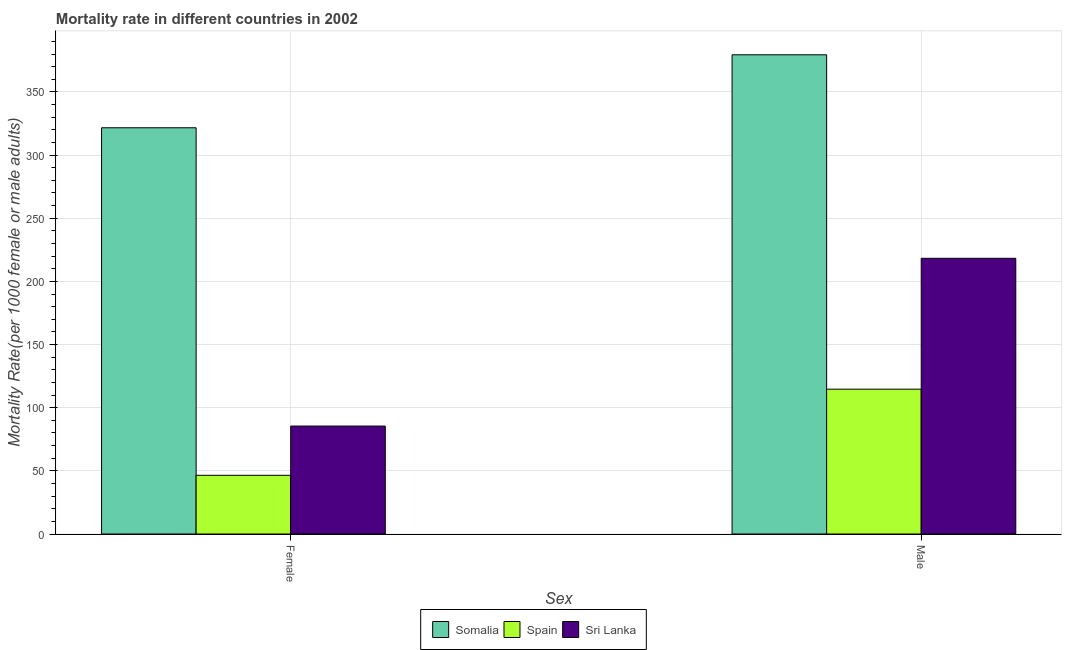How many groups of bars are there?
Make the answer very short. 2. How many bars are there on the 2nd tick from the left?
Your answer should be compact. 3. How many bars are there on the 1st tick from the right?
Your response must be concise. 3. What is the male mortality rate in Sri Lanka?
Offer a terse response. 218.29. Across all countries, what is the maximum female mortality rate?
Your answer should be compact. 321.64. Across all countries, what is the minimum male mortality rate?
Ensure brevity in your answer.  114.67. In which country was the female mortality rate maximum?
Your answer should be compact. Somalia. What is the total female mortality rate in the graph?
Give a very brief answer. 453.57. What is the difference between the female mortality rate in Spain and that in Somalia?
Offer a very short reply. -275.16. What is the difference between the female mortality rate in Spain and the male mortality rate in Somalia?
Keep it short and to the point. -332.96. What is the average female mortality rate per country?
Your answer should be compact. 151.19. What is the difference between the male mortality rate and female mortality rate in Sri Lanka?
Your answer should be compact. 132.83. What is the ratio of the female mortality rate in Somalia to that in Sri Lanka?
Your answer should be compact. 3.76. In how many countries, is the female mortality rate greater than the average female mortality rate taken over all countries?
Your answer should be compact. 1. What does the 1st bar from the left in Male represents?
Give a very brief answer. Somalia. What does the 3rd bar from the right in Female represents?
Give a very brief answer. Somalia. How many bars are there?
Offer a very short reply. 6. Are all the bars in the graph horizontal?
Your response must be concise. No. How many countries are there in the graph?
Your response must be concise. 3. What is the difference between two consecutive major ticks on the Y-axis?
Offer a terse response. 50. Are the values on the major ticks of Y-axis written in scientific E-notation?
Your answer should be very brief. No. Does the graph contain any zero values?
Give a very brief answer. No. How are the legend labels stacked?
Provide a succinct answer. Horizontal. What is the title of the graph?
Provide a succinct answer. Mortality rate in different countries in 2002. What is the label or title of the X-axis?
Offer a very short reply. Sex. What is the label or title of the Y-axis?
Provide a short and direct response. Mortality Rate(per 1000 female or male adults). What is the Mortality Rate(per 1000 female or male adults) of Somalia in Female?
Offer a terse response. 321.64. What is the Mortality Rate(per 1000 female or male adults) of Spain in Female?
Provide a succinct answer. 46.47. What is the Mortality Rate(per 1000 female or male adults) of Sri Lanka in Female?
Your answer should be very brief. 85.46. What is the Mortality Rate(per 1000 female or male adults) in Somalia in Male?
Provide a short and direct response. 379.43. What is the Mortality Rate(per 1000 female or male adults) of Spain in Male?
Make the answer very short. 114.67. What is the Mortality Rate(per 1000 female or male adults) of Sri Lanka in Male?
Make the answer very short. 218.29. Across all Sex, what is the maximum Mortality Rate(per 1000 female or male adults) in Somalia?
Offer a very short reply. 379.43. Across all Sex, what is the maximum Mortality Rate(per 1000 female or male adults) of Spain?
Your response must be concise. 114.67. Across all Sex, what is the maximum Mortality Rate(per 1000 female or male adults) of Sri Lanka?
Provide a succinct answer. 218.29. Across all Sex, what is the minimum Mortality Rate(per 1000 female or male adults) in Somalia?
Keep it short and to the point. 321.64. Across all Sex, what is the minimum Mortality Rate(per 1000 female or male adults) in Spain?
Offer a terse response. 46.47. Across all Sex, what is the minimum Mortality Rate(per 1000 female or male adults) in Sri Lanka?
Provide a succinct answer. 85.46. What is the total Mortality Rate(per 1000 female or male adults) of Somalia in the graph?
Keep it short and to the point. 701.07. What is the total Mortality Rate(per 1000 female or male adults) of Spain in the graph?
Your answer should be compact. 161.15. What is the total Mortality Rate(per 1000 female or male adults) of Sri Lanka in the graph?
Your answer should be very brief. 303.75. What is the difference between the Mortality Rate(per 1000 female or male adults) in Somalia in Female and that in Male?
Keep it short and to the point. -57.79. What is the difference between the Mortality Rate(per 1000 female or male adults) in Spain in Female and that in Male?
Provide a short and direct response. -68.2. What is the difference between the Mortality Rate(per 1000 female or male adults) of Sri Lanka in Female and that in Male?
Your answer should be compact. -132.83. What is the difference between the Mortality Rate(per 1000 female or male adults) of Somalia in Female and the Mortality Rate(per 1000 female or male adults) of Spain in Male?
Provide a short and direct response. 206.96. What is the difference between the Mortality Rate(per 1000 female or male adults) in Somalia in Female and the Mortality Rate(per 1000 female or male adults) in Sri Lanka in Male?
Make the answer very short. 103.35. What is the difference between the Mortality Rate(per 1000 female or male adults) of Spain in Female and the Mortality Rate(per 1000 female or male adults) of Sri Lanka in Male?
Provide a short and direct response. -171.82. What is the average Mortality Rate(per 1000 female or male adults) of Somalia per Sex?
Your answer should be compact. 350.53. What is the average Mortality Rate(per 1000 female or male adults) in Spain per Sex?
Your answer should be compact. 80.57. What is the average Mortality Rate(per 1000 female or male adults) of Sri Lanka per Sex?
Your answer should be very brief. 151.88. What is the difference between the Mortality Rate(per 1000 female or male adults) in Somalia and Mortality Rate(per 1000 female or male adults) in Spain in Female?
Your answer should be very brief. 275.16. What is the difference between the Mortality Rate(per 1000 female or male adults) of Somalia and Mortality Rate(per 1000 female or male adults) of Sri Lanka in Female?
Offer a terse response. 236.17. What is the difference between the Mortality Rate(per 1000 female or male adults) of Spain and Mortality Rate(per 1000 female or male adults) of Sri Lanka in Female?
Provide a short and direct response. -38.99. What is the difference between the Mortality Rate(per 1000 female or male adults) in Somalia and Mortality Rate(per 1000 female or male adults) in Spain in Male?
Offer a very short reply. 264.75. What is the difference between the Mortality Rate(per 1000 female or male adults) in Somalia and Mortality Rate(per 1000 female or male adults) in Sri Lanka in Male?
Your answer should be very brief. 161.14. What is the difference between the Mortality Rate(per 1000 female or male adults) of Spain and Mortality Rate(per 1000 female or male adults) of Sri Lanka in Male?
Your answer should be very brief. -103.61. What is the ratio of the Mortality Rate(per 1000 female or male adults) in Somalia in Female to that in Male?
Make the answer very short. 0.85. What is the ratio of the Mortality Rate(per 1000 female or male adults) in Spain in Female to that in Male?
Keep it short and to the point. 0.41. What is the ratio of the Mortality Rate(per 1000 female or male adults) of Sri Lanka in Female to that in Male?
Offer a very short reply. 0.39. What is the difference between the highest and the second highest Mortality Rate(per 1000 female or male adults) of Somalia?
Your answer should be very brief. 57.79. What is the difference between the highest and the second highest Mortality Rate(per 1000 female or male adults) of Spain?
Your answer should be compact. 68.2. What is the difference between the highest and the second highest Mortality Rate(per 1000 female or male adults) of Sri Lanka?
Offer a very short reply. 132.83. What is the difference between the highest and the lowest Mortality Rate(per 1000 female or male adults) in Somalia?
Provide a short and direct response. 57.79. What is the difference between the highest and the lowest Mortality Rate(per 1000 female or male adults) in Spain?
Your answer should be very brief. 68.2. What is the difference between the highest and the lowest Mortality Rate(per 1000 female or male adults) of Sri Lanka?
Your answer should be very brief. 132.83. 